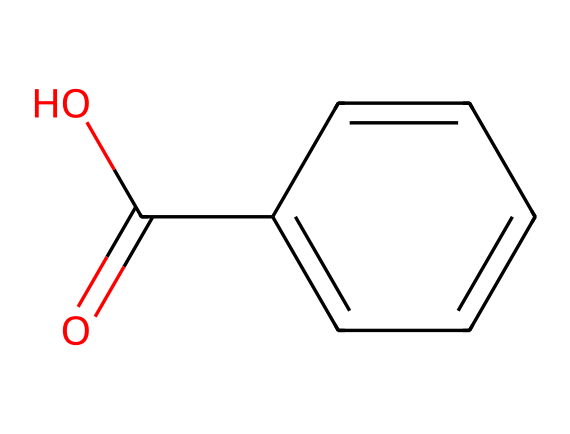What is the molecular formula of this chemical? By analyzing the structure from the SMILES representation, we can deduce the number of carbon (C), hydrogen (H), and oxygen (O) atoms present. There are 7 carbon atoms, 6 hydrogen atoms, and 3 oxygen atoms, leading to the molecular formula C7H6O3.
Answer: C7H6O3 How many rings are present in this chemical structure? A careful look at the structure indicates that it consists of a benzene ring, which is a six-membered carbon ring. Therefore, there is only one ring present in the structure.
Answer: 1 What type of functional groups are present in this chemical? The structure contains a carboxylic acid group (—COOH), indicated by the presence of a carbonyl (C=O) and a hydroxyl (—OH) group. It is also aromatic due to the benzene ring present. Therefore, the key functional groups are carboxylic acid and aromatic.
Answer: carboxylic acid, aromatic What physical state is this chemical likely to be at room temperature? Salicylic acid, represented by the given structure, is a solid at room temperature, as it typically has a high melting point due to strong intermolecular interactions (hydrogen bonding and pi stacking).
Answer: solid How does the presence of the hydroxyl group affect the solubility of this chemical? The hydroxyl group (-OH) enhances the solubility because it can form hydrogen bonds with water molecules, making the compound more polar and increasing solubility in aqueous solutions.
Answer: increases solubility What is the primary use of this chemical in medicine? Salicylic acid, derived from the structure, is primarily used as a topical treatment for acne and psoriasis, as well as an anti-inflammatory agent due to its ability to exfoliate and unclog pores.
Answer: topical treatment for acne and psoriasis 